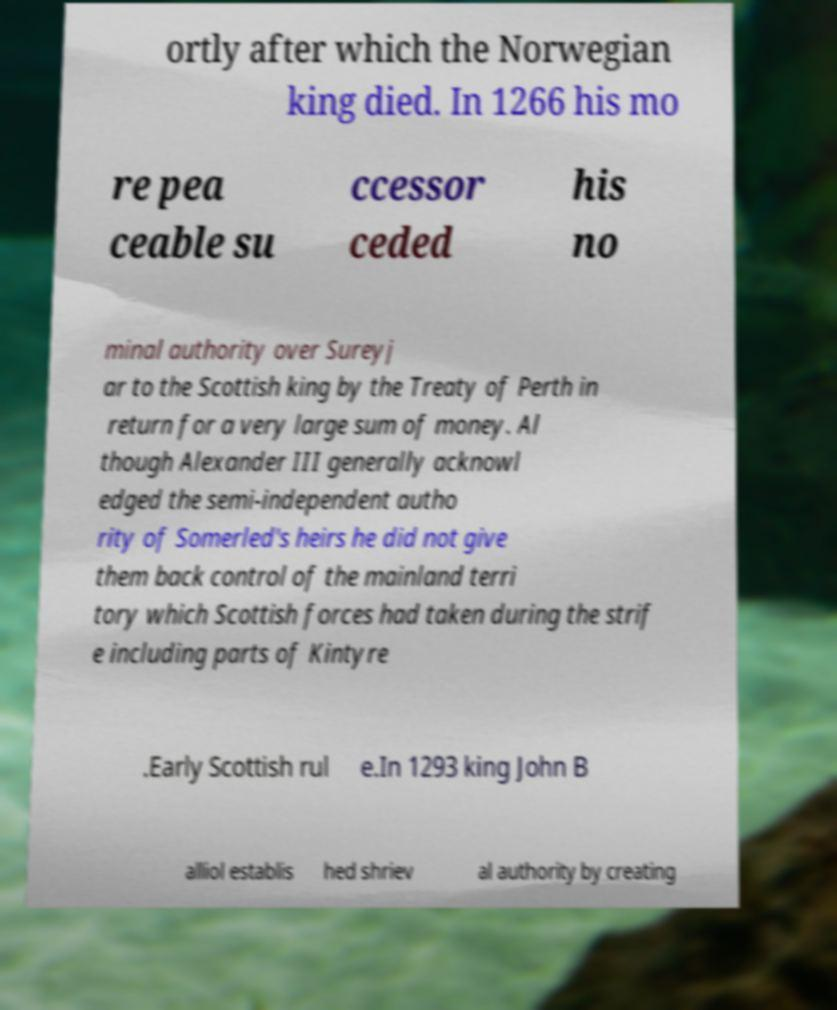What messages or text are displayed in this image? I need them in a readable, typed format. ortly after which the Norwegian king died. In 1266 his mo re pea ceable su ccessor ceded his no minal authority over Sureyj ar to the Scottish king by the Treaty of Perth in return for a very large sum of money. Al though Alexander III generally acknowl edged the semi-independent autho rity of Somerled's heirs he did not give them back control of the mainland terri tory which Scottish forces had taken during the strif e including parts of Kintyre .Early Scottish rul e.In 1293 king John B alliol establis hed shriev al authority by creating 